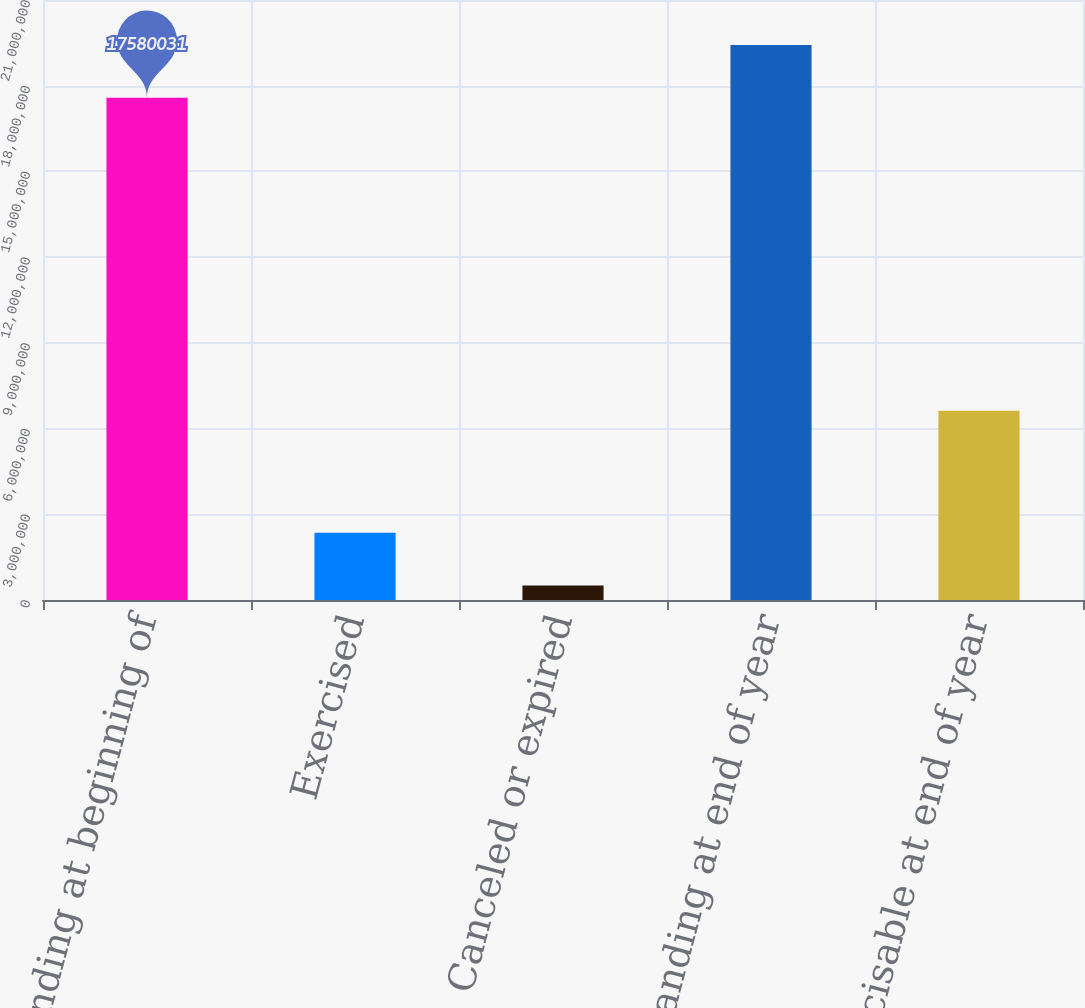Convert chart to OTSL. <chart><loc_0><loc_0><loc_500><loc_500><bar_chart><fcel>Outstanding at beginning of<fcel>Exercised<fcel>Canceled or expired<fcel>Outstanding at end of year<fcel>Exercisable at end of year<nl><fcel>1.758e+07<fcel>2.35353e+06<fcel>508083<fcel>1.94255e+07<fcel>6.62634e+06<nl></chart> 